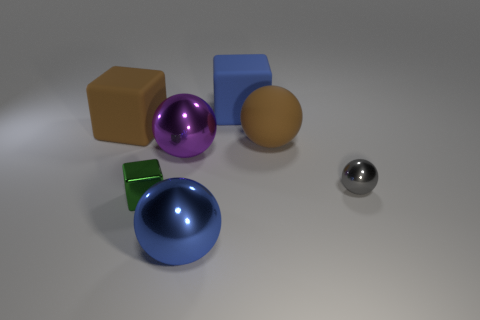Subtract 1 balls. How many balls are left? 3 Add 3 brown rubber objects. How many objects exist? 10 Subtract all cubes. How many objects are left? 4 Subtract 0 yellow blocks. How many objects are left? 7 Subtract all large purple spheres. Subtract all gray spheres. How many objects are left? 5 Add 7 brown rubber things. How many brown rubber things are left? 9 Add 1 gray things. How many gray things exist? 2 